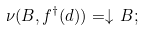Convert formula to latex. <formula><loc_0><loc_0><loc_500><loc_500>\nu ( B , f ^ { \dagger } ( d ) ) = \downarrow \, B ;</formula> 